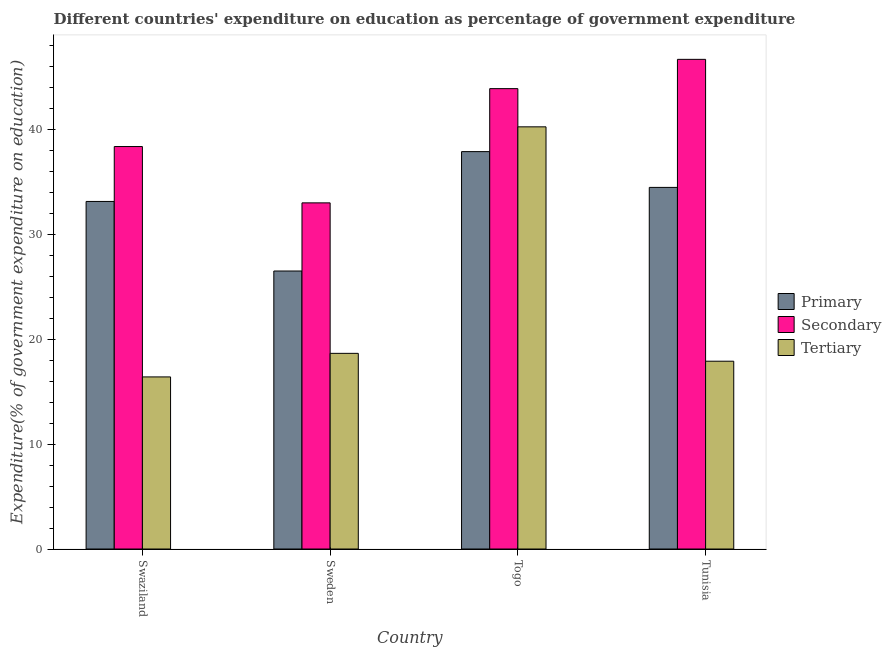How many different coloured bars are there?
Offer a very short reply. 3. Are the number of bars per tick equal to the number of legend labels?
Ensure brevity in your answer.  Yes. What is the label of the 1st group of bars from the left?
Provide a short and direct response. Swaziland. What is the expenditure on secondary education in Togo?
Keep it short and to the point. 43.92. Across all countries, what is the maximum expenditure on primary education?
Ensure brevity in your answer.  37.91. Across all countries, what is the minimum expenditure on secondary education?
Keep it short and to the point. 33.02. In which country was the expenditure on tertiary education maximum?
Your response must be concise. Togo. In which country was the expenditure on tertiary education minimum?
Offer a very short reply. Swaziland. What is the total expenditure on secondary education in the graph?
Provide a succinct answer. 162.03. What is the difference between the expenditure on primary education in Togo and that in Tunisia?
Your response must be concise. 3.41. What is the difference between the expenditure on primary education in Tunisia and the expenditure on tertiary education in Sweden?
Offer a very short reply. 15.83. What is the average expenditure on tertiary education per country?
Your answer should be compact. 23.32. What is the difference between the expenditure on primary education and expenditure on secondary education in Tunisia?
Provide a succinct answer. -12.21. What is the ratio of the expenditure on secondary education in Sweden to that in Togo?
Offer a terse response. 0.75. Is the difference between the expenditure on secondary education in Sweden and Togo greater than the difference between the expenditure on tertiary education in Sweden and Togo?
Ensure brevity in your answer.  Yes. What is the difference between the highest and the second highest expenditure on secondary education?
Ensure brevity in your answer.  2.79. What is the difference between the highest and the lowest expenditure on primary education?
Give a very brief answer. 11.39. What does the 3rd bar from the left in Togo represents?
Keep it short and to the point. Tertiary. What does the 3rd bar from the right in Sweden represents?
Your response must be concise. Primary. Is it the case that in every country, the sum of the expenditure on primary education and expenditure on secondary education is greater than the expenditure on tertiary education?
Your response must be concise. Yes. Are all the bars in the graph horizontal?
Your response must be concise. No. What is the difference between two consecutive major ticks on the Y-axis?
Give a very brief answer. 10. Does the graph contain grids?
Give a very brief answer. No. What is the title of the graph?
Give a very brief answer. Different countries' expenditure on education as percentage of government expenditure. Does "Infant(female)" appear as one of the legend labels in the graph?
Your answer should be very brief. No. What is the label or title of the X-axis?
Make the answer very short. Country. What is the label or title of the Y-axis?
Provide a succinct answer. Expenditure(% of government expenditure on education). What is the Expenditure(% of government expenditure on education) in Primary in Swaziland?
Make the answer very short. 33.15. What is the Expenditure(% of government expenditure on education) in Secondary in Swaziland?
Ensure brevity in your answer.  38.39. What is the Expenditure(% of government expenditure on education) of Tertiary in Swaziland?
Give a very brief answer. 16.42. What is the Expenditure(% of government expenditure on education) in Primary in Sweden?
Keep it short and to the point. 26.52. What is the Expenditure(% of government expenditure on education) in Secondary in Sweden?
Offer a very short reply. 33.02. What is the Expenditure(% of government expenditure on education) of Tertiary in Sweden?
Provide a short and direct response. 18.66. What is the Expenditure(% of government expenditure on education) of Primary in Togo?
Keep it short and to the point. 37.91. What is the Expenditure(% of government expenditure on education) in Secondary in Togo?
Your answer should be compact. 43.92. What is the Expenditure(% of government expenditure on education) in Tertiary in Togo?
Keep it short and to the point. 40.27. What is the Expenditure(% of government expenditure on education) in Primary in Tunisia?
Provide a succinct answer. 34.49. What is the Expenditure(% of government expenditure on education) of Secondary in Tunisia?
Make the answer very short. 46.71. What is the Expenditure(% of government expenditure on education) in Tertiary in Tunisia?
Keep it short and to the point. 17.91. Across all countries, what is the maximum Expenditure(% of government expenditure on education) in Primary?
Offer a terse response. 37.91. Across all countries, what is the maximum Expenditure(% of government expenditure on education) in Secondary?
Provide a succinct answer. 46.71. Across all countries, what is the maximum Expenditure(% of government expenditure on education) of Tertiary?
Your response must be concise. 40.27. Across all countries, what is the minimum Expenditure(% of government expenditure on education) in Primary?
Provide a short and direct response. 26.52. Across all countries, what is the minimum Expenditure(% of government expenditure on education) of Secondary?
Provide a short and direct response. 33.02. Across all countries, what is the minimum Expenditure(% of government expenditure on education) in Tertiary?
Offer a terse response. 16.42. What is the total Expenditure(% of government expenditure on education) of Primary in the graph?
Offer a very short reply. 132.07. What is the total Expenditure(% of government expenditure on education) in Secondary in the graph?
Ensure brevity in your answer.  162.03. What is the total Expenditure(% of government expenditure on education) in Tertiary in the graph?
Your answer should be very brief. 93.26. What is the difference between the Expenditure(% of government expenditure on education) in Primary in Swaziland and that in Sweden?
Make the answer very short. 6.64. What is the difference between the Expenditure(% of government expenditure on education) in Secondary in Swaziland and that in Sweden?
Provide a short and direct response. 5.37. What is the difference between the Expenditure(% of government expenditure on education) of Tertiary in Swaziland and that in Sweden?
Provide a short and direct response. -2.25. What is the difference between the Expenditure(% of government expenditure on education) of Primary in Swaziland and that in Togo?
Provide a short and direct response. -4.75. What is the difference between the Expenditure(% of government expenditure on education) of Secondary in Swaziland and that in Togo?
Offer a terse response. -5.52. What is the difference between the Expenditure(% of government expenditure on education) in Tertiary in Swaziland and that in Togo?
Give a very brief answer. -23.85. What is the difference between the Expenditure(% of government expenditure on education) in Primary in Swaziland and that in Tunisia?
Ensure brevity in your answer.  -1.34. What is the difference between the Expenditure(% of government expenditure on education) of Secondary in Swaziland and that in Tunisia?
Provide a succinct answer. -8.32. What is the difference between the Expenditure(% of government expenditure on education) of Tertiary in Swaziland and that in Tunisia?
Keep it short and to the point. -1.5. What is the difference between the Expenditure(% of government expenditure on education) in Primary in Sweden and that in Togo?
Offer a terse response. -11.39. What is the difference between the Expenditure(% of government expenditure on education) in Secondary in Sweden and that in Togo?
Ensure brevity in your answer.  -10.9. What is the difference between the Expenditure(% of government expenditure on education) of Tertiary in Sweden and that in Togo?
Offer a terse response. -21.61. What is the difference between the Expenditure(% of government expenditure on education) of Primary in Sweden and that in Tunisia?
Make the answer very short. -7.98. What is the difference between the Expenditure(% of government expenditure on education) in Secondary in Sweden and that in Tunisia?
Your answer should be compact. -13.69. What is the difference between the Expenditure(% of government expenditure on education) in Tertiary in Sweden and that in Tunisia?
Ensure brevity in your answer.  0.75. What is the difference between the Expenditure(% of government expenditure on education) of Primary in Togo and that in Tunisia?
Your answer should be compact. 3.41. What is the difference between the Expenditure(% of government expenditure on education) in Secondary in Togo and that in Tunisia?
Offer a terse response. -2.79. What is the difference between the Expenditure(% of government expenditure on education) in Tertiary in Togo and that in Tunisia?
Provide a short and direct response. 22.36. What is the difference between the Expenditure(% of government expenditure on education) in Primary in Swaziland and the Expenditure(% of government expenditure on education) in Secondary in Sweden?
Ensure brevity in your answer.  0.13. What is the difference between the Expenditure(% of government expenditure on education) of Primary in Swaziland and the Expenditure(% of government expenditure on education) of Tertiary in Sweden?
Your response must be concise. 14.49. What is the difference between the Expenditure(% of government expenditure on education) in Secondary in Swaziland and the Expenditure(% of government expenditure on education) in Tertiary in Sweden?
Your answer should be very brief. 19.73. What is the difference between the Expenditure(% of government expenditure on education) in Primary in Swaziland and the Expenditure(% of government expenditure on education) in Secondary in Togo?
Provide a succinct answer. -10.76. What is the difference between the Expenditure(% of government expenditure on education) in Primary in Swaziland and the Expenditure(% of government expenditure on education) in Tertiary in Togo?
Offer a very short reply. -7.12. What is the difference between the Expenditure(% of government expenditure on education) in Secondary in Swaziland and the Expenditure(% of government expenditure on education) in Tertiary in Togo?
Offer a very short reply. -1.88. What is the difference between the Expenditure(% of government expenditure on education) in Primary in Swaziland and the Expenditure(% of government expenditure on education) in Secondary in Tunisia?
Your answer should be compact. -13.55. What is the difference between the Expenditure(% of government expenditure on education) in Primary in Swaziland and the Expenditure(% of government expenditure on education) in Tertiary in Tunisia?
Your response must be concise. 15.24. What is the difference between the Expenditure(% of government expenditure on education) of Secondary in Swaziland and the Expenditure(% of government expenditure on education) of Tertiary in Tunisia?
Give a very brief answer. 20.48. What is the difference between the Expenditure(% of government expenditure on education) in Primary in Sweden and the Expenditure(% of government expenditure on education) in Secondary in Togo?
Provide a short and direct response. -17.4. What is the difference between the Expenditure(% of government expenditure on education) of Primary in Sweden and the Expenditure(% of government expenditure on education) of Tertiary in Togo?
Your answer should be compact. -13.75. What is the difference between the Expenditure(% of government expenditure on education) in Secondary in Sweden and the Expenditure(% of government expenditure on education) in Tertiary in Togo?
Ensure brevity in your answer.  -7.25. What is the difference between the Expenditure(% of government expenditure on education) in Primary in Sweden and the Expenditure(% of government expenditure on education) in Secondary in Tunisia?
Your response must be concise. -20.19. What is the difference between the Expenditure(% of government expenditure on education) in Primary in Sweden and the Expenditure(% of government expenditure on education) in Tertiary in Tunisia?
Offer a very short reply. 8.6. What is the difference between the Expenditure(% of government expenditure on education) in Secondary in Sweden and the Expenditure(% of government expenditure on education) in Tertiary in Tunisia?
Offer a very short reply. 15.1. What is the difference between the Expenditure(% of government expenditure on education) in Primary in Togo and the Expenditure(% of government expenditure on education) in Secondary in Tunisia?
Offer a terse response. -8.8. What is the difference between the Expenditure(% of government expenditure on education) in Primary in Togo and the Expenditure(% of government expenditure on education) in Tertiary in Tunisia?
Keep it short and to the point. 19.99. What is the difference between the Expenditure(% of government expenditure on education) of Secondary in Togo and the Expenditure(% of government expenditure on education) of Tertiary in Tunisia?
Ensure brevity in your answer.  26. What is the average Expenditure(% of government expenditure on education) of Primary per country?
Your response must be concise. 33.02. What is the average Expenditure(% of government expenditure on education) in Secondary per country?
Make the answer very short. 40.51. What is the average Expenditure(% of government expenditure on education) of Tertiary per country?
Keep it short and to the point. 23.32. What is the difference between the Expenditure(% of government expenditure on education) of Primary and Expenditure(% of government expenditure on education) of Secondary in Swaziland?
Your answer should be compact. -5.24. What is the difference between the Expenditure(% of government expenditure on education) in Primary and Expenditure(% of government expenditure on education) in Tertiary in Swaziland?
Keep it short and to the point. 16.74. What is the difference between the Expenditure(% of government expenditure on education) of Secondary and Expenditure(% of government expenditure on education) of Tertiary in Swaziland?
Provide a succinct answer. 21.98. What is the difference between the Expenditure(% of government expenditure on education) of Primary and Expenditure(% of government expenditure on education) of Secondary in Sweden?
Give a very brief answer. -6.5. What is the difference between the Expenditure(% of government expenditure on education) of Primary and Expenditure(% of government expenditure on education) of Tertiary in Sweden?
Provide a succinct answer. 7.85. What is the difference between the Expenditure(% of government expenditure on education) in Secondary and Expenditure(% of government expenditure on education) in Tertiary in Sweden?
Make the answer very short. 14.36. What is the difference between the Expenditure(% of government expenditure on education) of Primary and Expenditure(% of government expenditure on education) of Secondary in Togo?
Your response must be concise. -6.01. What is the difference between the Expenditure(% of government expenditure on education) of Primary and Expenditure(% of government expenditure on education) of Tertiary in Togo?
Your response must be concise. -2.36. What is the difference between the Expenditure(% of government expenditure on education) in Secondary and Expenditure(% of government expenditure on education) in Tertiary in Togo?
Offer a very short reply. 3.64. What is the difference between the Expenditure(% of government expenditure on education) of Primary and Expenditure(% of government expenditure on education) of Secondary in Tunisia?
Offer a terse response. -12.21. What is the difference between the Expenditure(% of government expenditure on education) in Primary and Expenditure(% of government expenditure on education) in Tertiary in Tunisia?
Your answer should be compact. 16.58. What is the difference between the Expenditure(% of government expenditure on education) of Secondary and Expenditure(% of government expenditure on education) of Tertiary in Tunisia?
Your answer should be compact. 28.79. What is the ratio of the Expenditure(% of government expenditure on education) in Primary in Swaziland to that in Sweden?
Offer a terse response. 1.25. What is the ratio of the Expenditure(% of government expenditure on education) of Secondary in Swaziland to that in Sweden?
Keep it short and to the point. 1.16. What is the ratio of the Expenditure(% of government expenditure on education) of Tertiary in Swaziland to that in Sweden?
Keep it short and to the point. 0.88. What is the ratio of the Expenditure(% of government expenditure on education) in Primary in Swaziland to that in Togo?
Your answer should be very brief. 0.87. What is the ratio of the Expenditure(% of government expenditure on education) of Secondary in Swaziland to that in Togo?
Your answer should be compact. 0.87. What is the ratio of the Expenditure(% of government expenditure on education) in Tertiary in Swaziland to that in Togo?
Your answer should be compact. 0.41. What is the ratio of the Expenditure(% of government expenditure on education) in Primary in Swaziland to that in Tunisia?
Provide a succinct answer. 0.96. What is the ratio of the Expenditure(% of government expenditure on education) in Secondary in Swaziland to that in Tunisia?
Your response must be concise. 0.82. What is the ratio of the Expenditure(% of government expenditure on education) in Tertiary in Swaziland to that in Tunisia?
Your answer should be very brief. 0.92. What is the ratio of the Expenditure(% of government expenditure on education) of Primary in Sweden to that in Togo?
Your answer should be compact. 0.7. What is the ratio of the Expenditure(% of government expenditure on education) in Secondary in Sweden to that in Togo?
Keep it short and to the point. 0.75. What is the ratio of the Expenditure(% of government expenditure on education) in Tertiary in Sweden to that in Togo?
Your answer should be very brief. 0.46. What is the ratio of the Expenditure(% of government expenditure on education) in Primary in Sweden to that in Tunisia?
Your answer should be very brief. 0.77. What is the ratio of the Expenditure(% of government expenditure on education) of Secondary in Sweden to that in Tunisia?
Provide a succinct answer. 0.71. What is the ratio of the Expenditure(% of government expenditure on education) in Tertiary in Sweden to that in Tunisia?
Make the answer very short. 1.04. What is the ratio of the Expenditure(% of government expenditure on education) of Primary in Togo to that in Tunisia?
Ensure brevity in your answer.  1.1. What is the ratio of the Expenditure(% of government expenditure on education) of Secondary in Togo to that in Tunisia?
Your answer should be compact. 0.94. What is the ratio of the Expenditure(% of government expenditure on education) in Tertiary in Togo to that in Tunisia?
Your response must be concise. 2.25. What is the difference between the highest and the second highest Expenditure(% of government expenditure on education) of Primary?
Your response must be concise. 3.41. What is the difference between the highest and the second highest Expenditure(% of government expenditure on education) of Secondary?
Give a very brief answer. 2.79. What is the difference between the highest and the second highest Expenditure(% of government expenditure on education) in Tertiary?
Provide a succinct answer. 21.61. What is the difference between the highest and the lowest Expenditure(% of government expenditure on education) in Primary?
Keep it short and to the point. 11.39. What is the difference between the highest and the lowest Expenditure(% of government expenditure on education) of Secondary?
Keep it short and to the point. 13.69. What is the difference between the highest and the lowest Expenditure(% of government expenditure on education) in Tertiary?
Your answer should be compact. 23.85. 